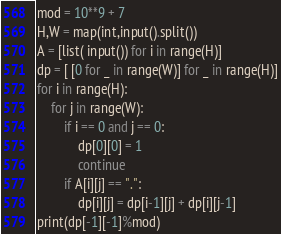Convert code to text. <code><loc_0><loc_0><loc_500><loc_500><_Python_>mod = 10**9 + 7
H,W = map(int,input().split())
A = [list( input()) for i in range(H)]
dp = [ [0 for _ in range(W)] for _ in range(H)]
for i in range(H):
    for j in range(W):
        if i == 0 and j == 0:
            dp[0][0] = 1
            continue
        if A[i][j] == ".":
            dp[i][j] = dp[i-1][j] + dp[i][j-1] 
print(dp[-1][-1]%mod)
</code> 